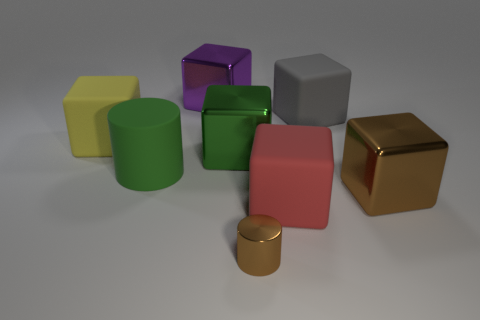Subtract all brown blocks. How many blocks are left? 5 Add 1 yellow things. How many objects exist? 9 Subtract all blocks. How many objects are left? 2 Subtract all red blocks. How many blocks are left? 5 Subtract all green cylinders. Subtract all red cubes. How many cylinders are left? 1 Subtract all yellow cylinders. How many purple cubes are left? 1 Subtract all big red rubber cubes. Subtract all yellow metal cubes. How many objects are left? 7 Add 7 matte cylinders. How many matte cylinders are left? 8 Add 5 blue rubber cylinders. How many blue rubber cylinders exist? 5 Subtract 1 green cylinders. How many objects are left? 7 